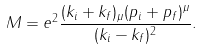Convert formula to latex. <formula><loc_0><loc_0><loc_500><loc_500>M = e ^ { 2 } \frac { ( k _ { i } + k _ { f } ) _ { \mu } ( p _ { i } + p _ { f } ) ^ { \mu } } { ( k _ { i } - k _ { f } ) ^ { 2 } } .</formula> 